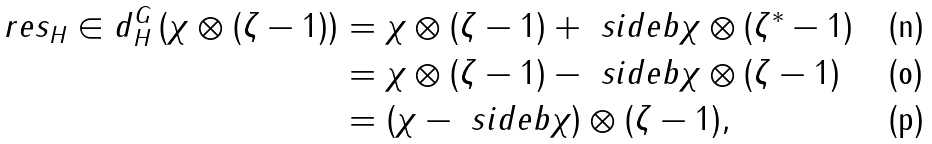<formula> <loc_0><loc_0><loc_500><loc_500>\ r e s _ { H } \in d _ { H } ^ { G } \left ( \chi \otimes ( \zeta - 1 ) \right ) & = \chi \otimes ( \zeta - 1 ) + \ s i d e { b } \chi \otimes ( \zeta ^ { * } - 1 ) \\ & = \chi \otimes ( \zeta - 1 ) - \ s i d e { b } \chi \otimes ( \zeta - 1 ) \\ & = ( \chi - \ s i d e { b } \chi ) \otimes ( \zeta - 1 ) ,</formula> 